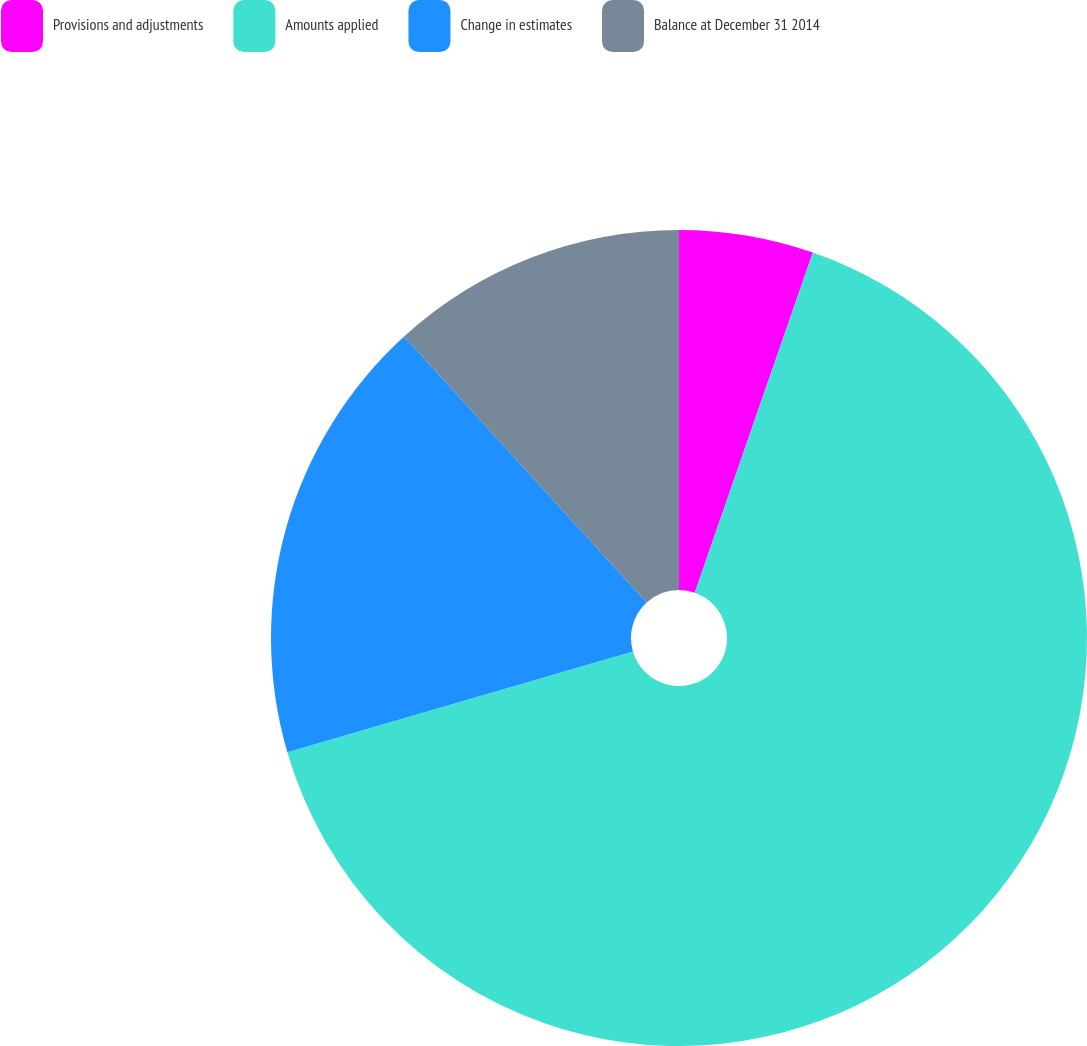Convert chart. <chart><loc_0><loc_0><loc_500><loc_500><pie_chart><fcel>Provisions and adjustments<fcel>Amounts applied<fcel>Change in estimates<fcel>Balance at December 31 2014<nl><fcel>5.32%<fcel>65.16%<fcel>17.75%<fcel>11.77%<nl></chart> 